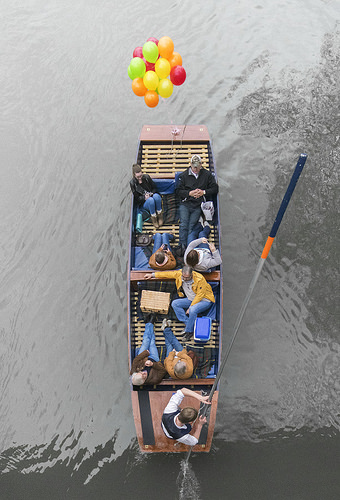<image>
Is the balloons on the people? No. The balloons is not positioned on the people. They may be near each other, but the balloons is not supported by or resting on top of the people. 